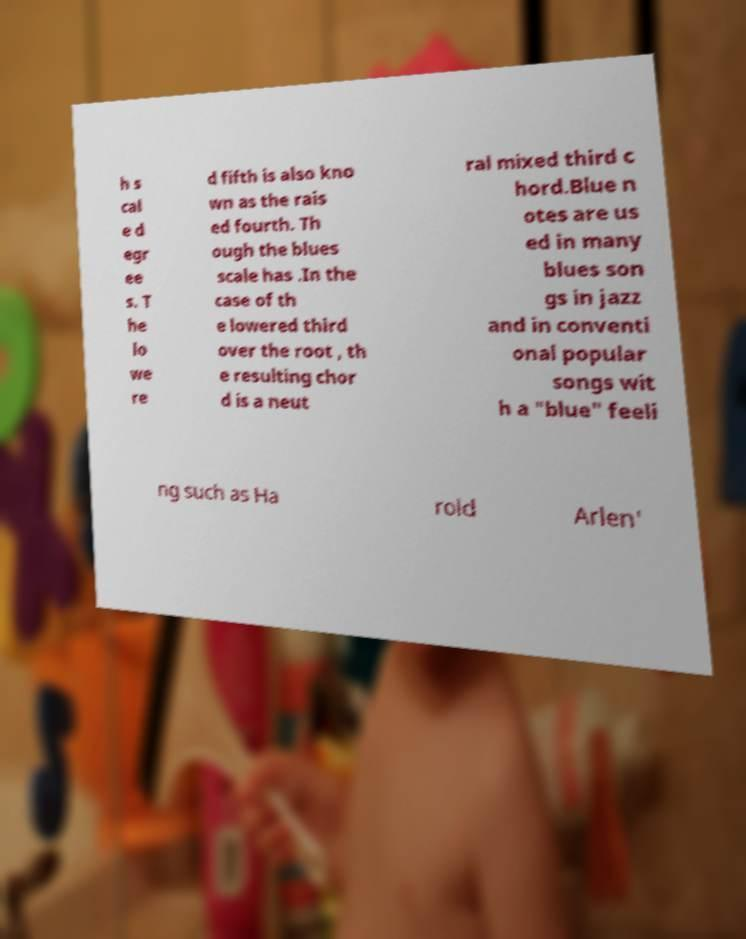I need the written content from this picture converted into text. Can you do that? h s cal e d egr ee s. T he lo we re d fifth is also kno wn as the rais ed fourth. Th ough the blues scale has .In the case of th e lowered third over the root , th e resulting chor d is a neut ral mixed third c hord.Blue n otes are us ed in many blues son gs in jazz and in conventi onal popular songs wit h a "blue" feeli ng such as Ha rold Arlen' 